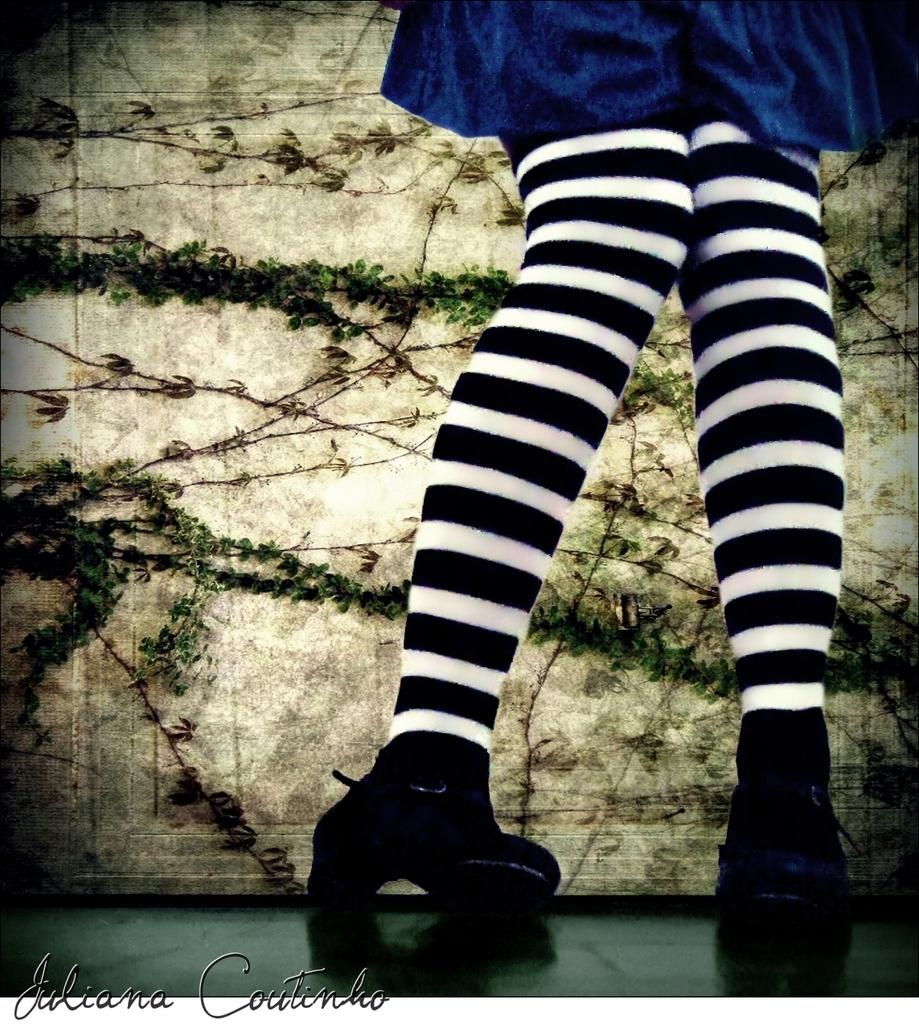What is visible in the foreground of the image? There are legs of a person in the foreground of the image. Whose legs are visible in the image? The legs belong to a person. What can be seen in the background of the image? There are branches of plants visible in the image. Where are the branches located in the image? The branches are on a surface. What type of haircut is the person getting in the image? There is no indication of a haircut in the image; it only shows the legs of a person and branches of plants. 